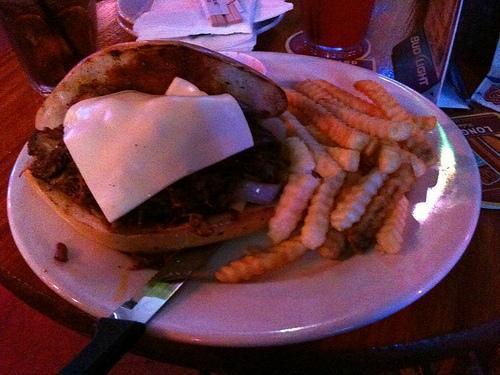How many pieces of cheese are there?
Give a very brief answer. 1. How many sandwiches are in the picture?
Give a very brief answer. 1. How many knives are there?
Give a very brief answer. 1. How many cups are in the photo?
Give a very brief answer. 2. How many dining tables are there?
Give a very brief answer. 1. 